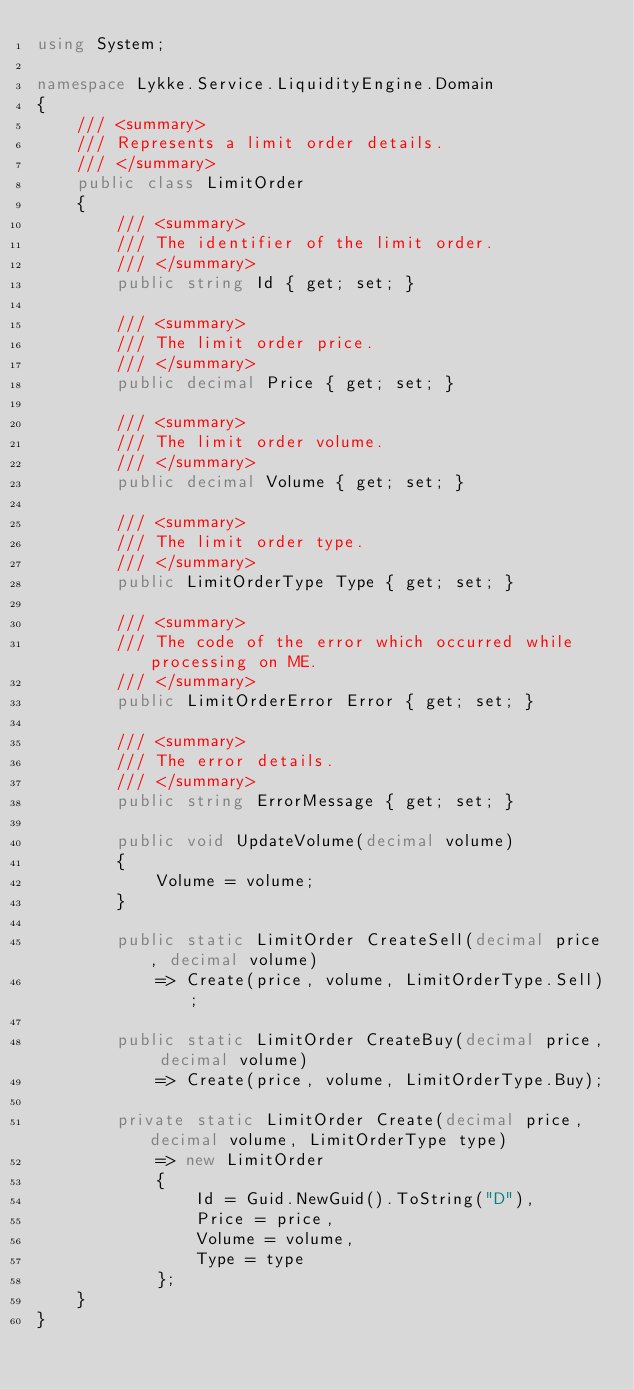<code> <loc_0><loc_0><loc_500><loc_500><_C#_>using System;

namespace Lykke.Service.LiquidityEngine.Domain
{
    /// <summary>
    /// Represents a limit order details.
    /// </summary>
    public class LimitOrder
    {
        /// <summary>
        /// The identifier of the limit order.
        /// </summary>
        public string Id { get; set; }

        /// <summary>
        /// The limit order price.
        /// </summary>
        public decimal Price { get; set; }

        /// <summary>
        /// The limit order volume.
        /// </summary>
        public decimal Volume { get; set; }

        /// <summary>
        /// The limit order type.
        /// </summary>
        public LimitOrderType Type { get; set; }

        /// <summary>
        /// The code of the error which occurred while processing on ME.
        /// </summary>
        public LimitOrderError Error { get; set; }

        /// <summary>
        /// The error details.
        /// </summary>
        public string ErrorMessage { get; set; }

        public void UpdateVolume(decimal volume)
        {
            Volume = volume;
        }
        
        public static LimitOrder CreateSell(decimal price, decimal volume)
            => Create(price, volume, LimitOrderType.Sell);

        public static LimitOrder CreateBuy(decimal price, decimal volume)
            => Create(price, volume, LimitOrderType.Buy);

        private static LimitOrder Create(decimal price, decimal volume, LimitOrderType type)
            => new LimitOrder
            {
                Id = Guid.NewGuid().ToString("D"),
                Price = price,
                Volume = volume,
                Type = type
            };
    }
}
</code> 